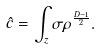Convert formula to latex. <formula><loc_0><loc_0><loc_500><loc_500>\hat { c } = \int _ { z } \sigma \rho ^ { \frac { D - 1 } { 2 } } .</formula> 